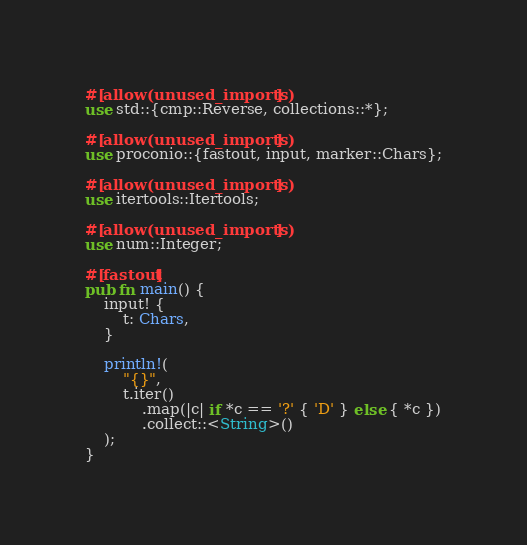Convert code to text. <code><loc_0><loc_0><loc_500><loc_500><_Rust_>#[allow(unused_imports)]
use std::{cmp::Reverse, collections::*};

#[allow(unused_imports)]
use proconio::{fastout, input, marker::Chars};

#[allow(unused_imports)]
use itertools::Itertools;

#[allow(unused_imports)]
use num::Integer;

#[fastout]
pub fn main() {
    input! {
        t: Chars,
    }

    println!(
        "{}",
        t.iter()
            .map(|c| if *c == '?' { 'D' } else { *c })
            .collect::<String>()
    );
}
</code> 